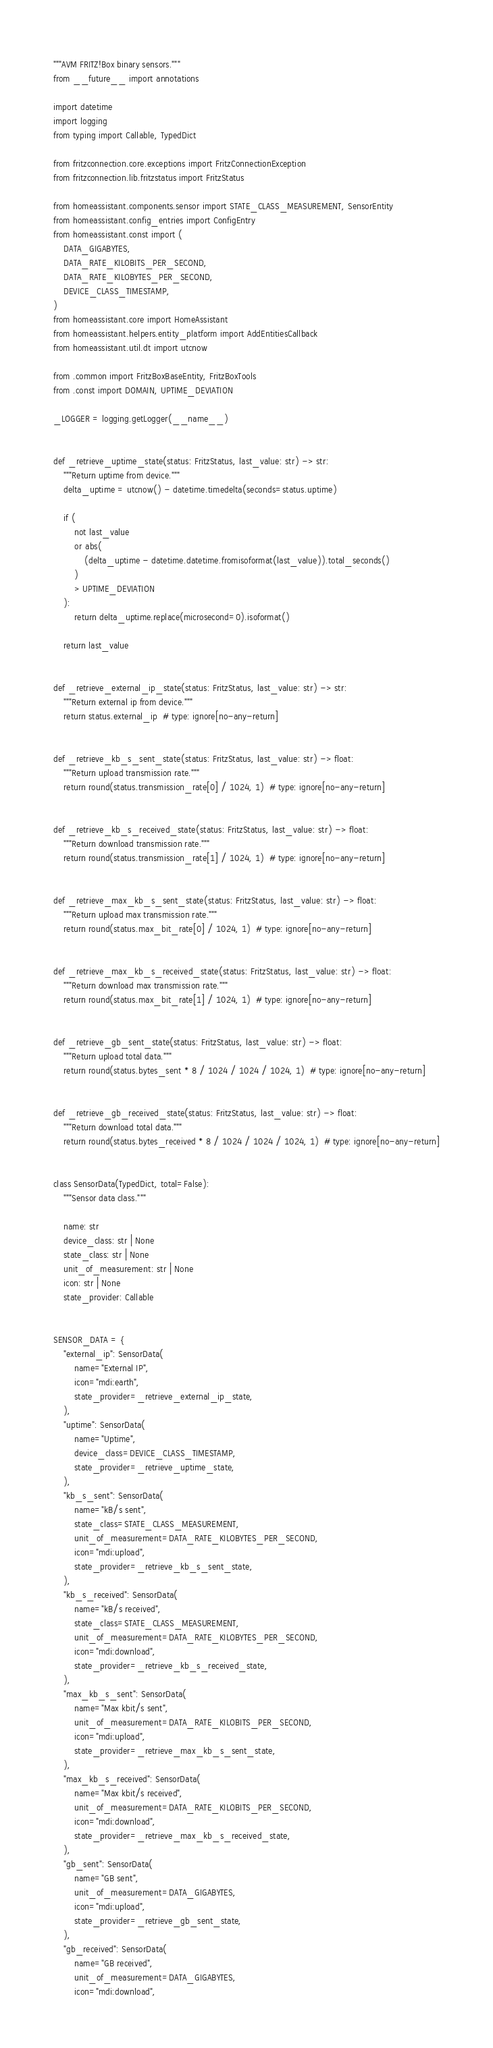<code> <loc_0><loc_0><loc_500><loc_500><_Python_>"""AVM FRITZ!Box binary sensors."""
from __future__ import annotations

import datetime
import logging
from typing import Callable, TypedDict

from fritzconnection.core.exceptions import FritzConnectionException
from fritzconnection.lib.fritzstatus import FritzStatus

from homeassistant.components.sensor import STATE_CLASS_MEASUREMENT, SensorEntity
from homeassistant.config_entries import ConfigEntry
from homeassistant.const import (
    DATA_GIGABYTES,
    DATA_RATE_KILOBITS_PER_SECOND,
    DATA_RATE_KILOBYTES_PER_SECOND,
    DEVICE_CLASS_TIMESTAMP,
)
from homeassistant.core import HomeAssistant
from homeassistant.helpers.entity_platform import AddEntitiesCallback
from homeassistant.util.dt import utcnow

from .common import FritzBoxBaseEntity, FritzBoxTools
from .const import DOMAIN, UPTIME_DEVIATION

_LOGGER = logging.getLogger(__name__)


def _retrieve_uptime_state(status: FritzStatus, last_value: str) -> str:
    """Return uptime from device."""
    delta_uptime = utcnow() - datetime.timedelta(seconds=status.uptime)

    if (
        not last_value
        or abs(
            (delta_uptime - datetime.datetime.fromisoformat(last_value)).total_seconds()
        )
        > UPTIME_DEVIATION
    ):
        return delta_uptime.replace(microsecond=0).isoformat()

    return last_value


def _retrieve_external_ip_state(status: FritzStatus, last_value: str) -> str:
    """Return external ip from device."""
    return status.external_ip  # type: ignore[no-any-return]


def _retrieve_kb_s_sent_state(status: FritzStatus, last_value: str) -> float:
    """Return upload transmission rate."""
    return round(status.transmission_rate[0] / 1024, 1)  # type: ignore[no-any-return]


def _retrieve_kb_s_received_state(status: FritzStatus, last_value: str) -> float:
    """Return download transmission rate."""
    return round(status.transmission_rate[1] / 1024, 1)  # type: ignore[no-any-return]


def _retrieve_max_kb_s_sent_state(status: FritzStatus, last_value: str) -> float:
    """Return upload max transmission rate."""
    return round(status.max_bit_rate[0] / 1024, 1)  # type: ignore[no-any-return]


def _retrieve_max_kb_s_received_state(status: FritzStatus, last_value: str) -> float:
    """Return download max transmission rate."""
    return round(status.max_bit_rate[1] / 1024, 1)  # type: ignore[no-any-return]


def _retrieve_gb_sent_state(status: FritzStatus, last_value: str) -> float:
    """Return upload total data."""
    return round(status.bytes_sent * 8 / 1024 / 1024 / 1024, 1)  # type: ignore[no-any-return]


def _retrieve_gb_received_state(status: FritzStatus, last_value: str) -> float:
    """Return download total data."""
    return round(status.bytes_received * 8 / 1024 / 1024 / 1024, 1)  # type: ignore[no-any-return]


class SensorData(TypedDict, total=False):
    """Sensor data class."""

    name: str
    device_class: str | None
    state_class: str | None
    unit_of_measurement: str | None
    icon: str | None
    state_provider: Callable


SENSOR_DATA = {
    "external_ip": SensorData(
        name="External IP",
        icon="mdi:earth",
        state_provider=_retrieve_external_ip_state,
    ),
    "uptime": SensorData(
        name="Uptime",
        device_class=DEVICE_CLASS_TIMESTAMP,
        state_provider=_retrieve_uptime_state,
    ),
    "kb_s_sent": SensorData(
        name="kB/s sent",
        state_class=STATE_CLASS_MEASUREMENT,
        unit_of_measurement=DATA_RATE_KILOBYTES_PER_SECOND,
        icon="mdi:upload",
        state_provider=_retrieve_kb_s_sent_state,
    ),
    "kb_s_received": SensorData(
        name="kB/s received",
        state_class=STATE_CLASS_MEASUREMENT,
        unit_of_measurement=DATA_RATE_KILOBYTES_PER_SECOND,
        icon="mdi:download",
        state_provider=_retrieve_kb_s_received_state,
    ),
    "max_kb_s_sent": SensorData(
        name="Max kbit/s sent",
        unit_of_measurement=DATA_RATE_KILOBITS_PER_SECOND,
        icon="mdi:upload",
        state_provider=_retrieve_max_kb_s_sent_state,
    ),
    "max_kb_s_received": SensorData(
        name="Max kbit/s received",
        unit_of_measurement=DATA_RATE_KILOBITS_PER_SECOND,
        icon="mdi:download",
        state_provider=_retrieve_max_kb_s_received_state,
    ),
    "gb_sent": SensorData(
        name="GB sent",
        unit_of_measurement=DATA_GIGABYTES,
        icon="mdi:upload",
        state_provider=_retrieve_gb_sent_state,
    ),
    "gb_received": SensorData(
        name="GB received",
        unit_of_measurement=DATA_GIGABYTES,
        icon="mdi:download",</code> 